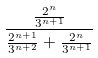<formula> <loc_0><loc_0><loc_500><loc_500>\frac { \frac { 2 ^ { n } } { 3 ^ { n + 1 } } } { \frac { 2 ^ { n + 1 } } { 3 ^ { n + 2 } } + \frac { 2 ^ { n } } { 3 ^ { n + 1 } } }</formula> 